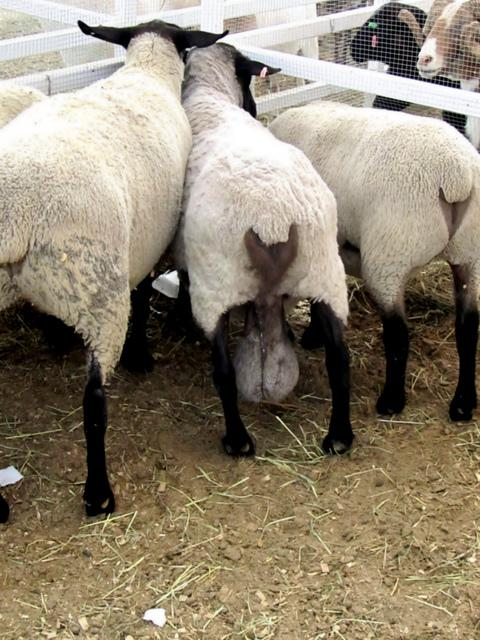What is hanging on the belly of the sheep in the middle? udder 